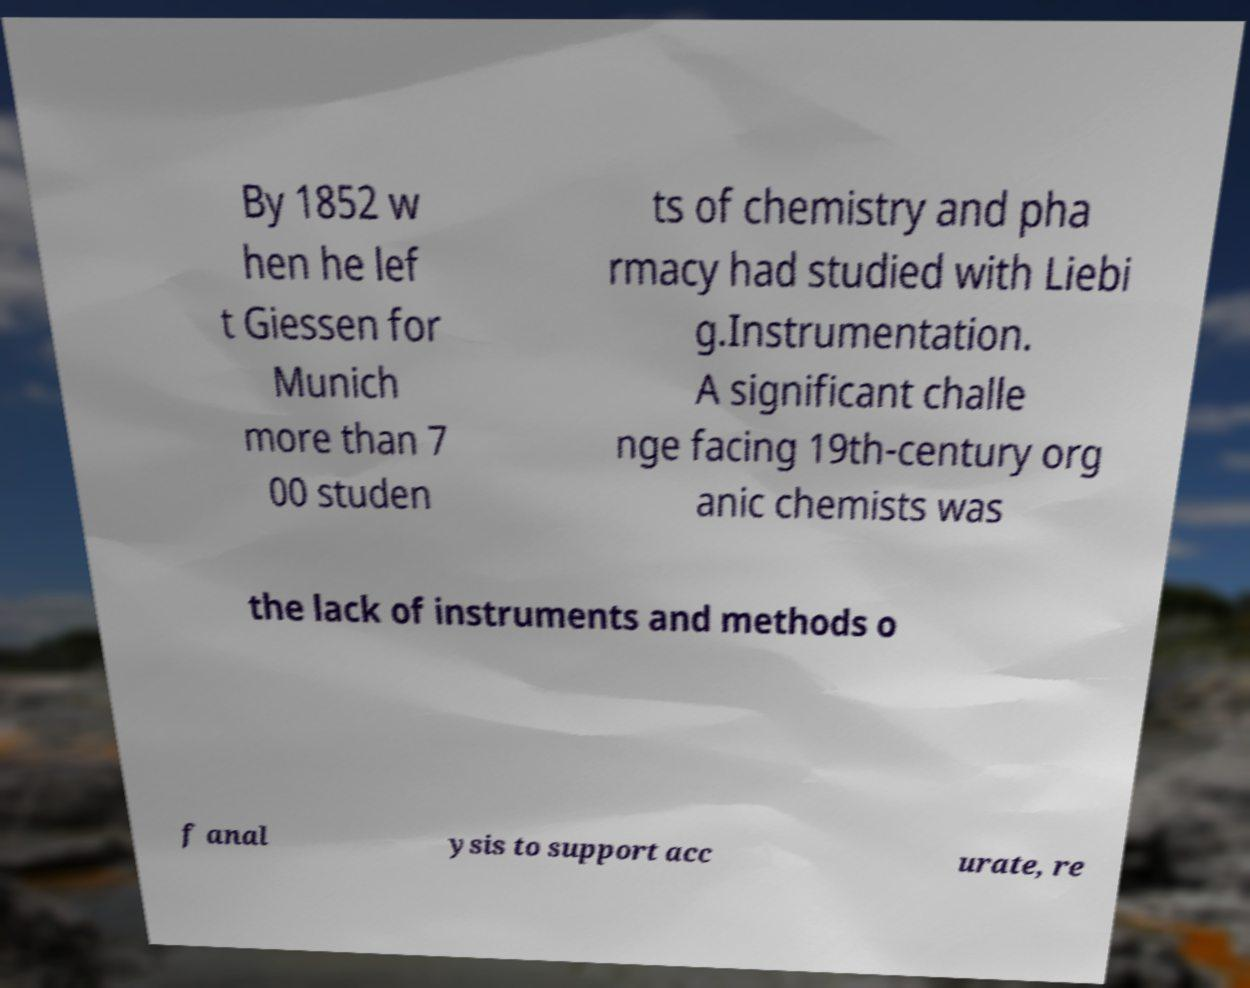There's text embedded in this image that I need extracted. Can you transcribe it verbatim? By 1852 w hen he lef t Giessen for Munich more than 7 00 studen ts of chemistry and pha rmacy had studied with Liebi g.Instrumentation. A significant challe nge facing 19th-century org anic chemists was the lack of instruments and methods o f anal ysis to support acc urate, re 